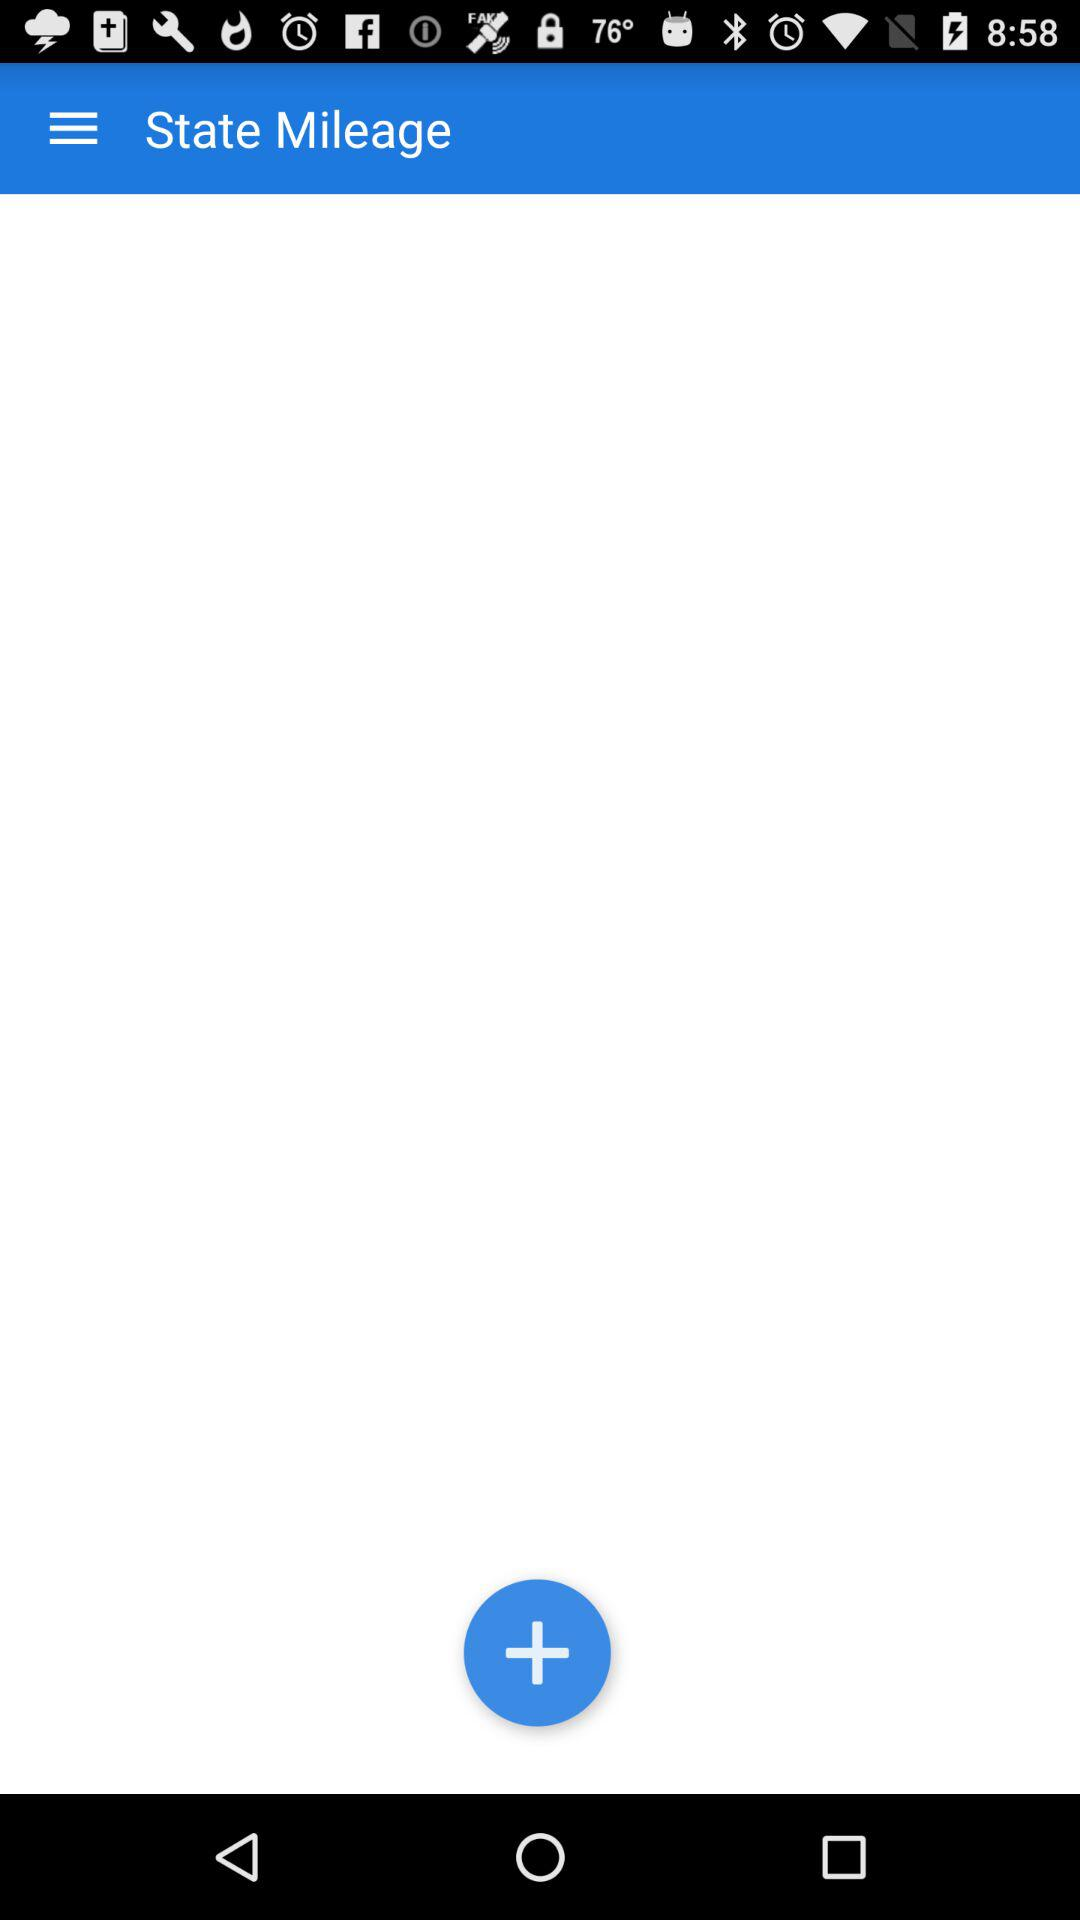If the mileage is 100 and I add 20, what will the new mileage be?
Answer the question using a single word or phrase. 120 